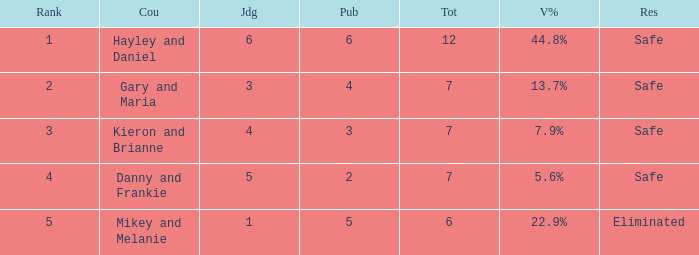How many public is there for the couple that got eliminated? 5.0. 